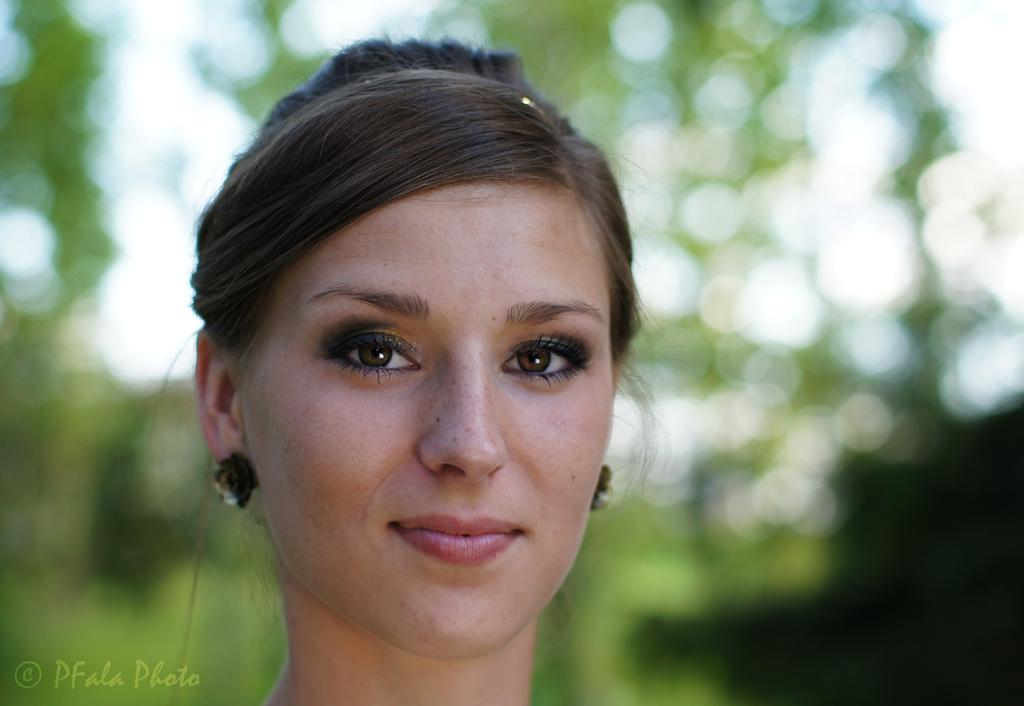Who is present in the image? There is a woman in the image. What invention is the woman using to express her anger in the image? There is no invention or expression of anger present in the image; it only features a woman. 